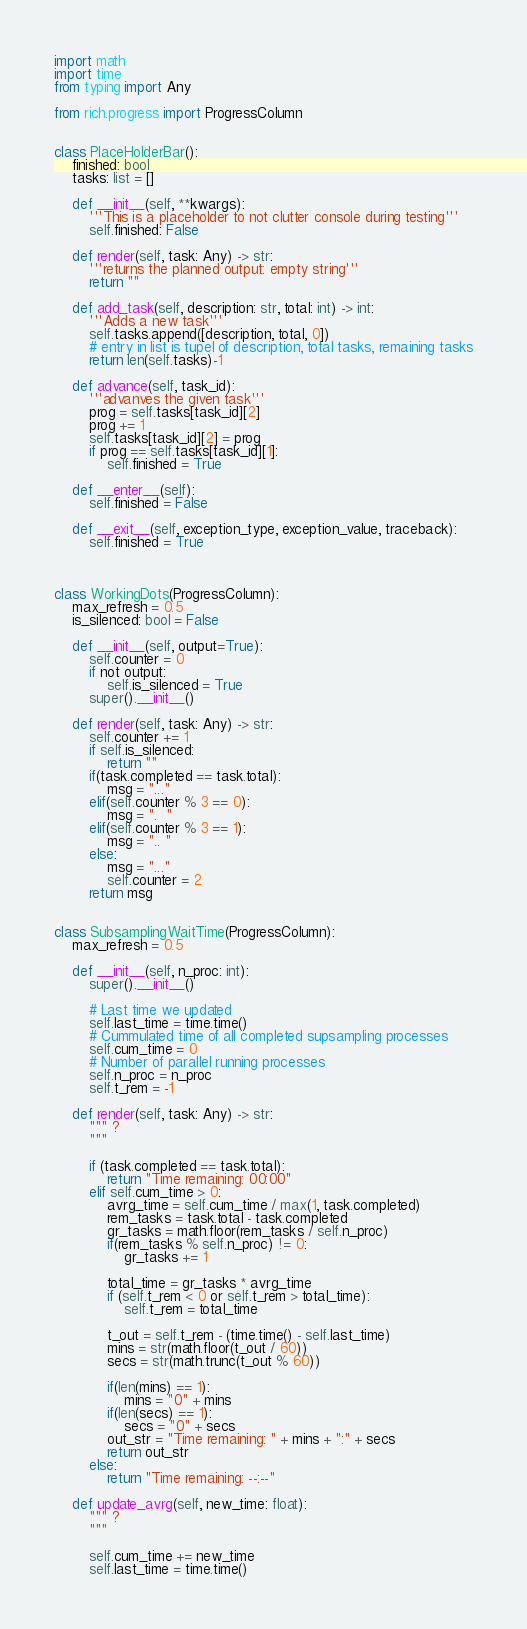Convert code to text. <code><loc_0><loc_0><loc_500><loc_500><_Python_>import math
import time
from typing import Any

from rich.progress import ProgressColumn


class PlaceHolderBar():
    finished: bool
    tasks: list = []

    def __init__(self, **kwargs):
        '''This is a placeholder to not clutter console during testing'''
        self.finished: False
    
    def render(self, task: Any) -> str:
        '''returns the planned output: empty string'''
        return ""
    
    def add_task(self, description: str, total: int) -> int:
        '''Adds a new task'''
        self.tasks.append([description, total, 0])
        # entry in list is tupel of description, total tasks, remaining tasks
        return len(self.tasks)-1
    
    def advance(self, task_id):
        '''advanves the given task'''
        prog = self.tasks[task_id][2]
        prog += 1
        self.tasks[task_id][2] = prog
        if prog == self.tasks[task_id][1]:
            self.finished = True
    
    def __enter__(self):
        self.finished = False
    
    def __exit__(self, exception_type, exception_value, traceback):
        self.finished = True
    


class WorkingDots(ProgressColumn):
    max_refresh = 0.5
    is_silenced: bool = False

    def __init__(self, output=True):
        self.counter = 0
        if not output:
            self.is_silenced = True
        super().__init__()

    def render(self, task: Any) -> str:
        self.counter += 1
        if self.is_silenced:
            return ""
        if(task.completed == task.total):
            msg = "..."
        elif(self.counter % 3 == 0):
            msg = ".  "
        elif(self.counter % 3 == 1):
            msg = ".. "
        else:
            msg = "..."
            self.counter = 2
        return msg


class SubsamplingWaitTime(ProgressColumn):
    max_refresh = 0.5

    def __init__(self, n_proc: int):
        super().__init__()

        # Last time we updated
        self.last_time = time.time()
        # Cummulated time of all completed supsampling processes
        self.cum_time = 0
        # Number of parallel running processes
        self.n_proc = n_proc
        self.t_rem = -1

    def render(self, task: Any) -> str:
        """ ?
        """

        if (task.completed == task.total):
            return "Time remaining: 00:00"
        elif self.cum_time > 0:
            avrg_time = self.cum_time / max(1, task.completed)
            rem_tasks = task.total - task.completed
            gr_tasks = math.floor(rem_tasks / self.n_proc)
            if(rem_tasks % self.n_proc) != 0:
                gr_tasks += 1

            total_time = gr_tasks * avrg_time
            if (self.t_rem < 0 or self.t_rem > total_time):
                self.t_rem = total_time

            t_out = self.t_rem - (time.time() - self.last_time)
            mins = str(math.floor(t_out / 60))
            secs = str(math.trunc(t_out % 60))

            if(len(mins) == 1):
                mins = "0" + mins
            if(len(secs) == 1):
                secs = "0" + secs
            out_str = "Time remaining: " + mins + ":" + secs
            return out_str
        else:
            return "Time remaining: --:--"

    def update_avrg(self, new_time: float):
        """ ?
        """

        self.cum_time += new_time
        self.last_time = time.time()
</code> 